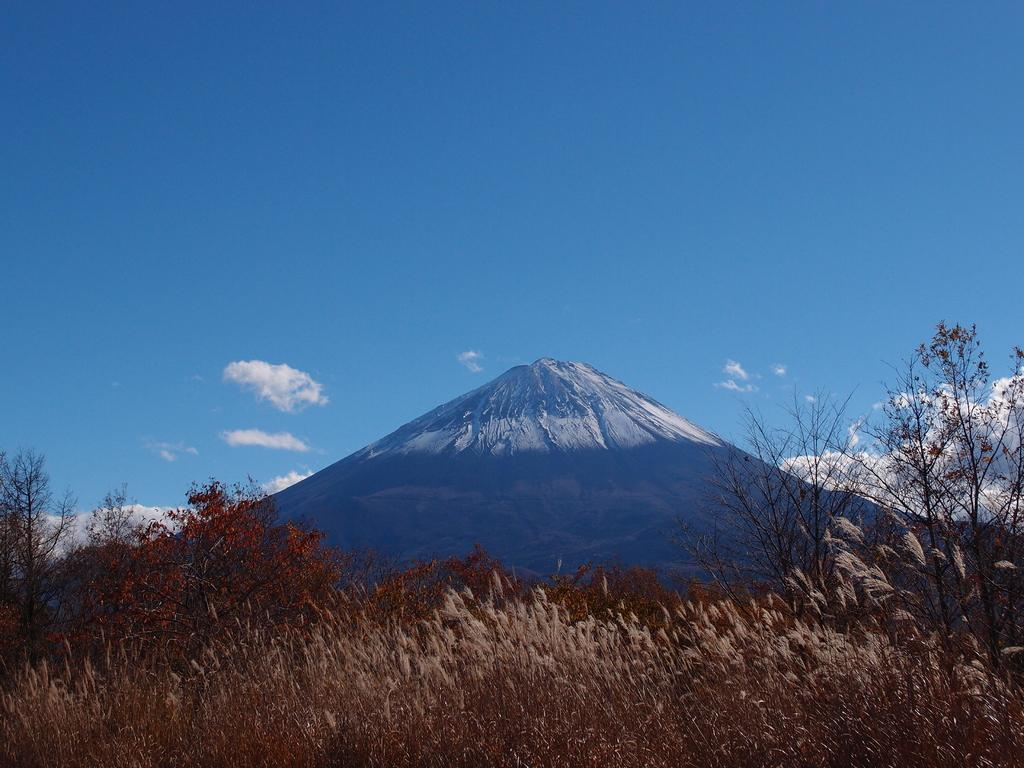What type of vegetation can be seen in the image? There are plants and trees in the image. What is visible in the background of the image? There are clouds and a mountain in the background of the image. What type of milk can be seen flowing from the branch in the image? There is no milk or branch present in the image. 